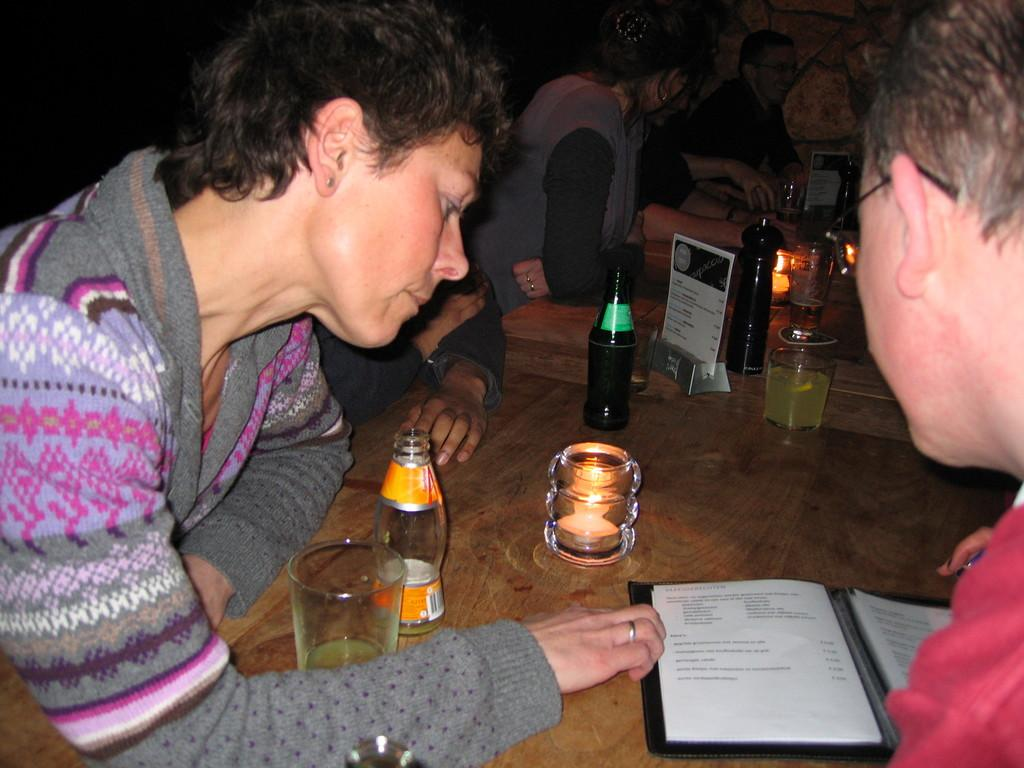What is happening with the persons in the image? The persons are sitting around the table. What type of surface is the table covered with? There is grass on the table. What can be seen on the table besides the grass? There is a beverage bottle, a candle, a menu, a book, and a lamp on the table. What type of tongue can be seen sticking out of the book in the image? There is no tongue present in the image, let alone sticking out of the book. 